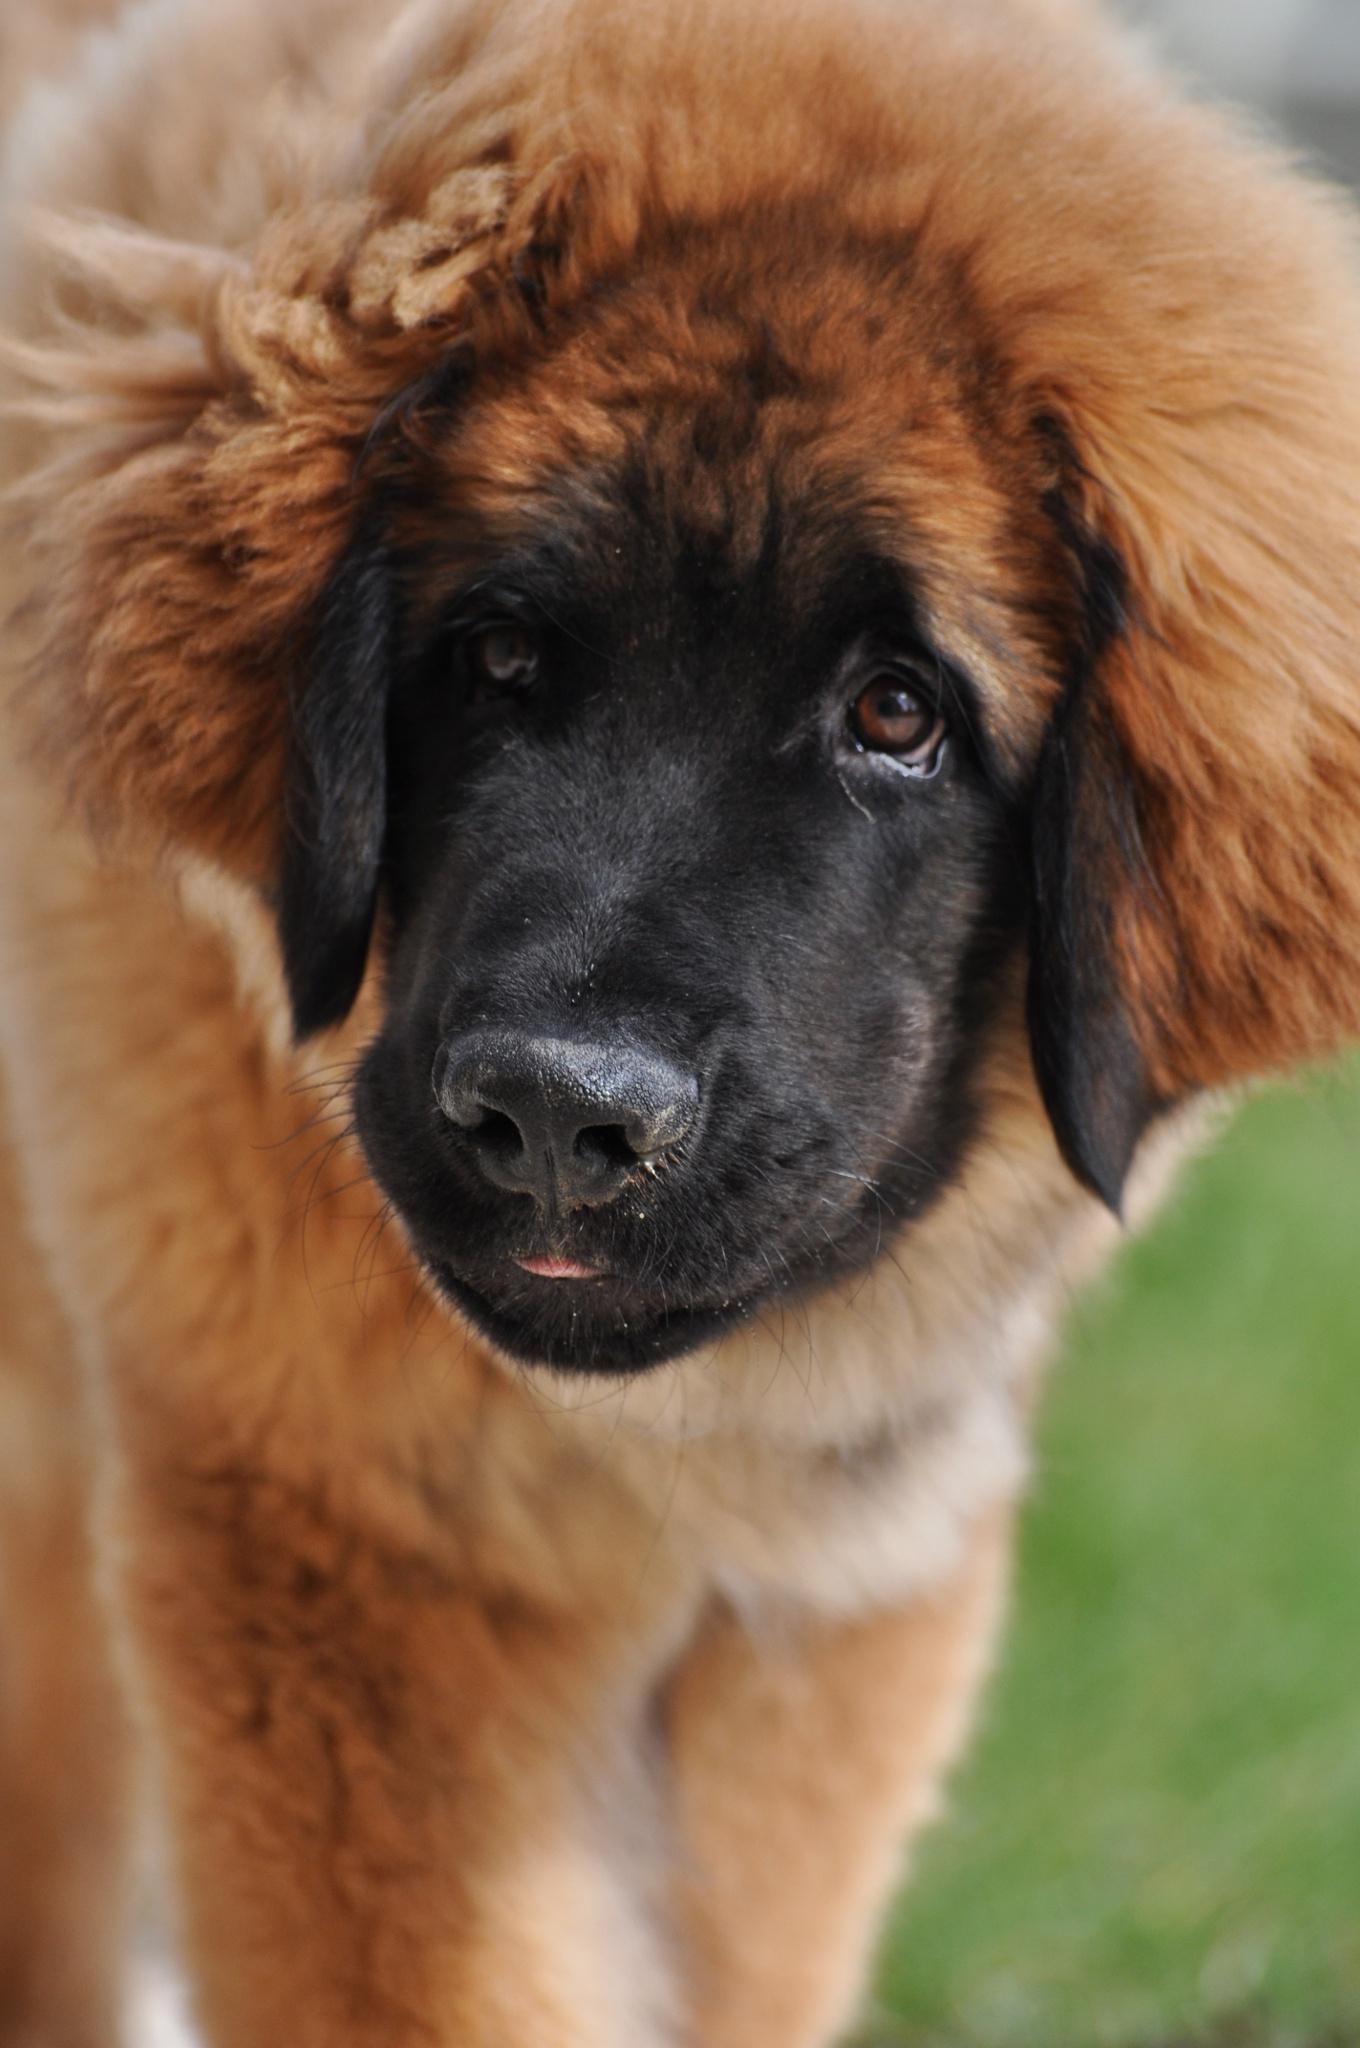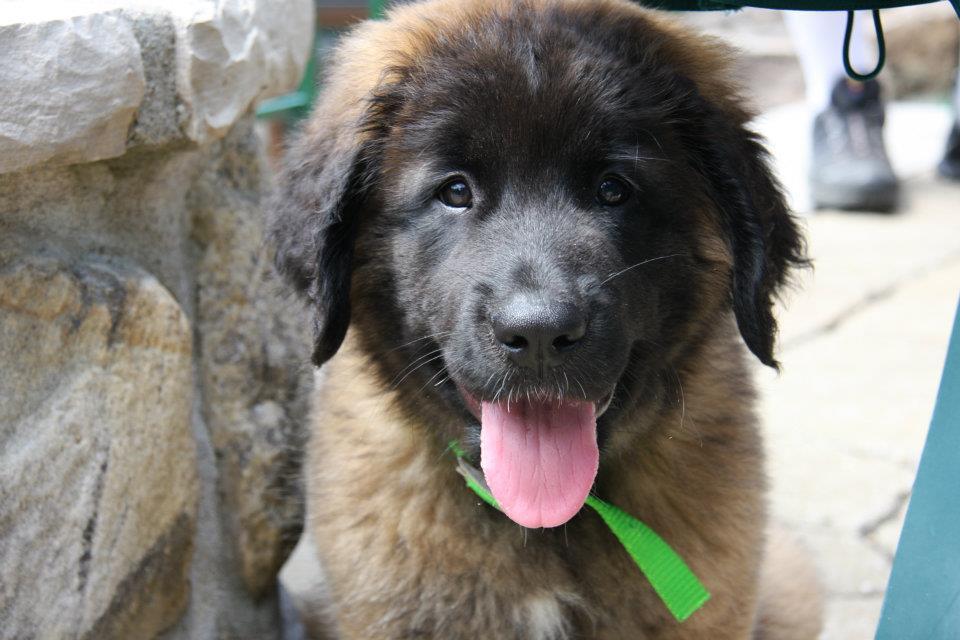The first image is the image on the left, the second image is the image on the right. For the images shown, is this caption "A larger animal is partly visible to the right of a puppy in an indoor setting." true? Answer yes or no. No. The first image is the image on the left, the second image is the image on the right. Evaluate the accuracy of this statement regarding the images: "There are two dogs, and one visible tongue.". Is it true? Answer yes or no. Yes. 